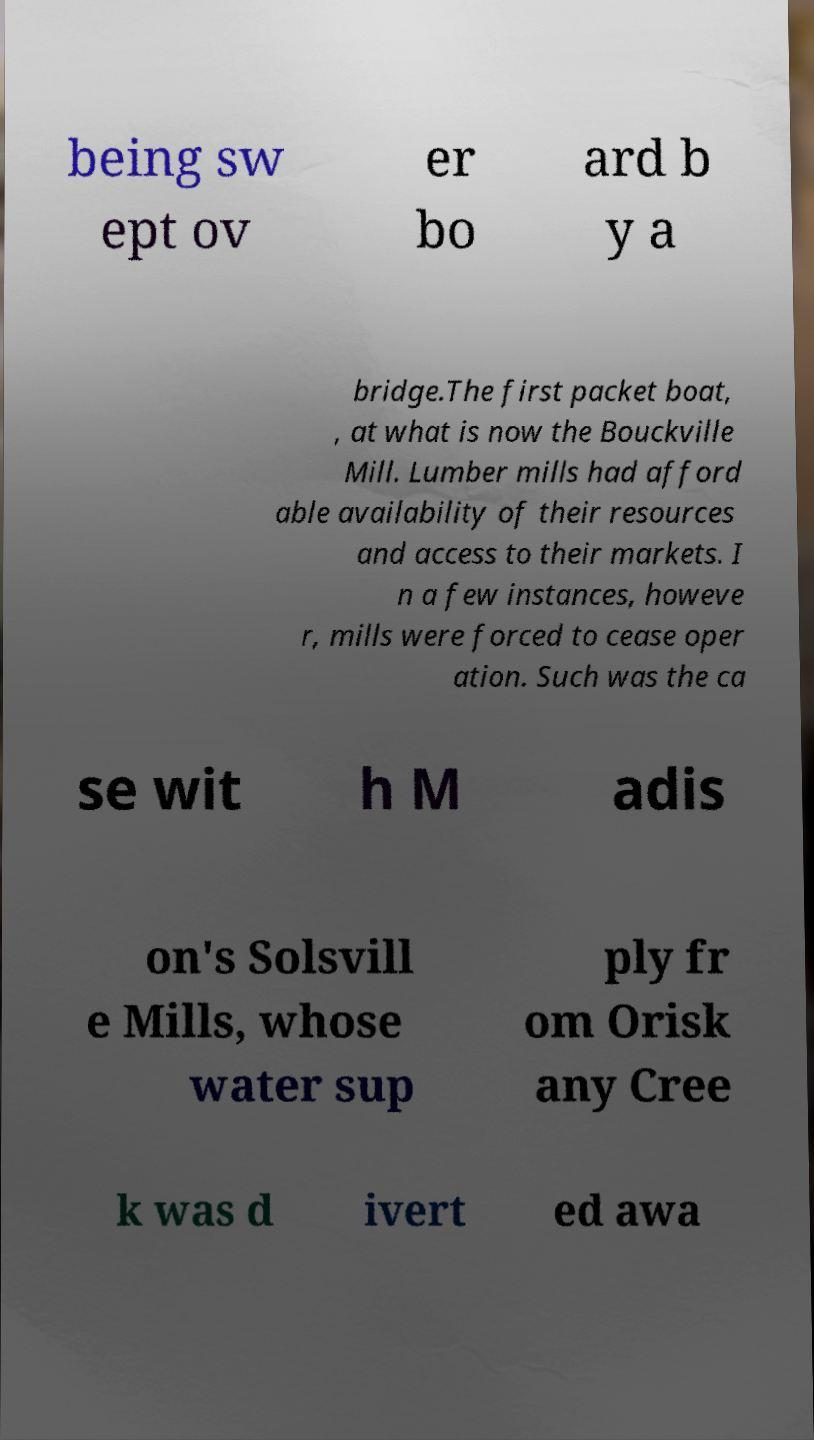I need the written content from this picture converted into text. Can you do that? being sw ept ov er bo ard b y a bridge.The first packet boat, , at what is now the Bouckville Mill. Lumber mills had afford able availability of their resources and access to their markets. I n a few instances, howeve r, mills were forced to cease oper ation. Such was the ca se wit h M adis on's Solsvill e Mills, whose water sup ply fr om Orisk any Cree k was d ivert ed awa 